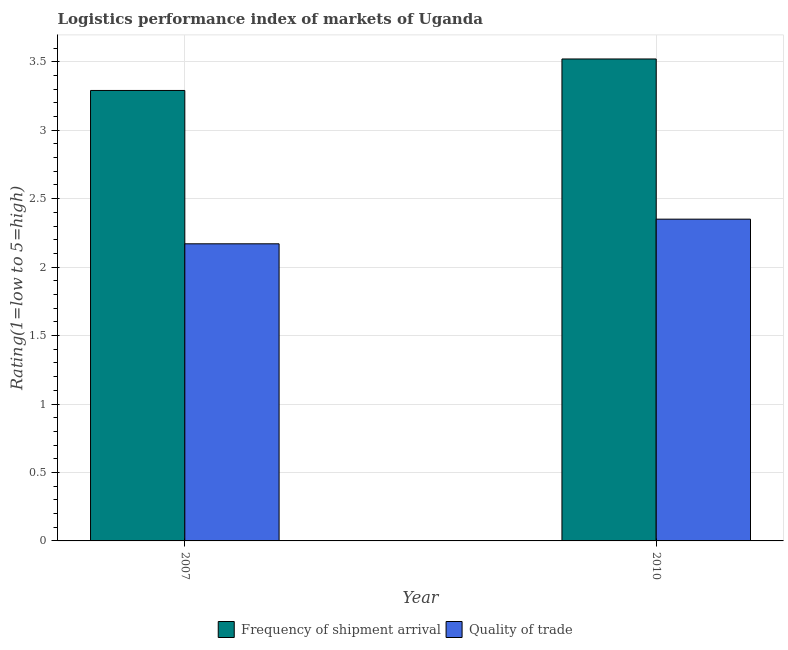How many different coloured bars are there?
Offer a terse response. 2. How many groups of bars are there?
Your response must be concise. 2. How many bars are there on the 2nd tick from the right?
Your answer should be compact. 2. What is the label of the 1st group of bars from the left?
Your answer should be very brief. 2007. What is the lpi quality of trade in 2010?
Give a very brief answer. 2.35. Across all years, what is the maximum lpi of frequency of shipment arrival?
Your answer should be very brief. 3.52. Across all years, what is the minimum lpi of frequency of shipment arrival?
Offer a very short reply. 3.29. In which year was the lpi of frequency of shipment arrival minimum?
Your answer should be very brief. 2007. What is the total lpi quality of trade in the graph?
Make the answer very short. 4.52. What is the difference between the lpi of frequency of shipment arrival in 2007 and that in 2010?
Keep it short and to the point. -0.23. What is the difference between the lpi quality of trade in 2010 and the lpi of frequency of shipment arrival in 2007?
Make the answer very short. 0.18. What is the average lpi of frequency of shipment arrival per year?
Your response must be concise. 3.41. In the year 2007, what is the difference between the lpi quality of trade and lpi of frequency of shipment arrival?
Provide a short and direct response. 0. What is the ratio of the lpi quality of trade in 2007 to that in 2010?
Give a very brief answer. 0.92. Is the lpi quality of trade in 2007 less than that in 2010?
Your answer should be compact. Yes. In how many years, is the lpi quality of trade greater than the average lpi quality of trade taken over all years?
Ensure brevity in your answer.  1. What does the 1st bar from the left in 2010 represents?
Keep it short and to the point. Frequency of shipment arrival. What does the 1st bar from the right in 2007 represents?
Make the answer very short. Quality of trade. How many bars are there?
Provide a short and direct response. 4. How many years are there in the graph?
Your response must be concise. 2. What is the difference between two consecutive major ticks on the Y-axis?
Ensure brevity in your answer.  0.5. Are the values on the major ticks of Y-axis written in scientific E-notation?
Your response must be concise. No. Does the graph contain any zero values?
Your answer should be compact. No. What is the title of the graph?
Your answer should be compact. Logistics performance index of markets of Uganda. What is the label or title of the X-axis?
Make the answer very short. Year. What is the label or title of the Y-axis?
Provide a short and direct response. Rating(1=low to 5=high). What is the Rating(1=low to 5=high) in Frequency of shipment arrival in 2007?
Your response must be concise. 3.29. What is the Rating(1=low to 5=high) of Quality of trade in 2007?
Keep it short and to the point. 2.17. What is the Rating(1=low to 5=high) of Frequency of shipment arrival in 2010?
Keep it short and to the point. 3.52. What is the Rating(1=low to 5=high) in Quality of trade in 2010?
Give a very brief answer. 2.35. Across all years, what is the maximum Rating(1=low to 5=high) of Frequency of shipment arrival?
Provide a succinct answer. 3.52. Across all years, what is the maximum Rating(1=low to 5=high) in Quality of trade?
Offer a very short reply. 2.35. Across all years, what is the minimum Rating(1=low to 5=high) of Frequency of shipment arrival?
Offer a terse response. 3.29. Across all years, what is the minimum Rating(1=low to 5=high) in Quality of trade?
Make the answer very short. 2.17. What is the total Rating(1=low to 5=high) of Frequency of shipment arrival in the graph?
Your response must be concise. 6.81. What is the total Rating(1=low to 5=high) of Quality of trade in the graph?
Ensure brevity in your answer.  4.52. What is the difference between the Rating(1=low to 5=high) in Frequency of shipment arrival in 2007 and that in 2010?
Your response must be concise. -0.23. What is the difference between the Rating(1=low to 5=high) in Quality of trade in 2007 and that in 2010?
Provide a short and direct response. -0.18. What is the difference between the Rating(1=low to 5=high) of Frequency of shipment arrival in 2007 and the Rating(1=low to 5=high) of Quality of trade in 2010?
Ensure brevity in your answer.  0.94. What is the average Rating(1=low to 5=high) of Frequency of shipment arrival per year?
Offer a terse response. 3.4. What is the average Rating(1=low to 5=high) in Quality of trade per year?
Ensure brevity in your answer.  2.26. In the year 2007, what is the difference between the Rating(1=low to 5=high) of Frequency of shipment arrival and Rating(1=low to 5=high) of Quality of trade?
Keep it short and to the point. 1.12. In the year 2010, what is the difference between the Rating(1=low to 5=high) in Frequency of shipment arrival and Rating(1=low to 5=high) in Quality of trade?
Provide a short and direct response. 1.17. What is the ratio of the Rating(1=low to 5=high) of Frequency of shipment arrival in 2007 to that in 2010?
Make the answer very short. 0.93. What is the ratio of the Rating(1=low to 5=high) of Quality of trade in 2007 to that in 2010?
Keep it short and to the point. 0.92. What is the difference between the highest and the second highest Rating(1=low to 5=high) in Frequency of shipment arrival?
Provide a succinct answer. 0.23. What is the difference between the highest and the second highest Rating(1=low to 5=high) in Quality of trade?
Make the answer very short. 0.18. What is the difference between the highest and the lowest Rating(1=low to 5=high) of Frequency of shipment arrival?
Your response must be concise. 0.23. What is the difference between the highest and the lowest Rating(1=low to 5=high) in Quality of trade?
Provide a short and direct response. 0.18. 